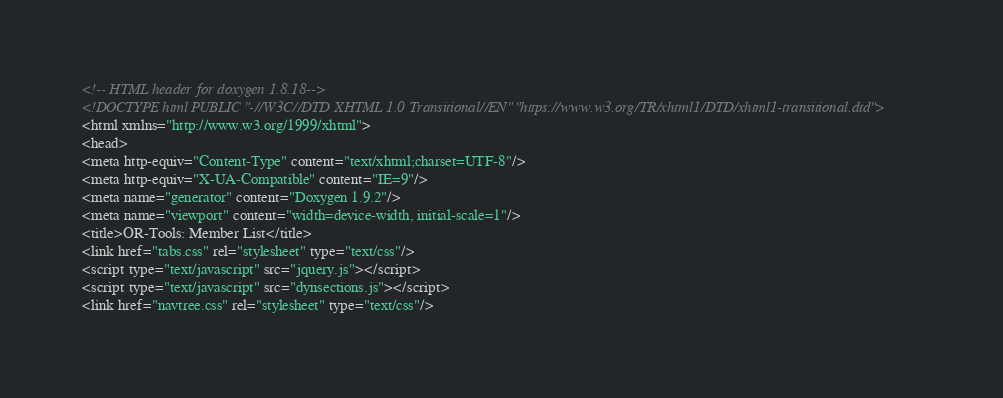Convert code to text. <code><loc_0><loc_0><loc_500><loc_500><_HTML_><!-- HTML header for doxygen 1.8.18-->
<!DOCTYPE html PUBLIC "-//W3C//DTD XHTML 1.0 Transitional//EN" "https://www.w3.org/TR/xhtml1/DTD/xhtml1-transitional.dtd">
<html xmlns="http://www.w3.org/1999/xhtml">
<head>
<meta http-equiv="Content-Type" content="text/xhtml;charset=UTF-8"/>
<meta http-equiv="X-UA-Compatible" content="IE=9"/>
<meta name="generator" content="Doxygen 1.9.2"/>
<meta name="viewport" content="width=device-width, initial-scale=1"/>
<title>OR-Tools: Member List</title>
<link href="tabs.css" rel="stylesheet" type="text/css"/>
<script type="text/javascript" src="jquery.js"></script>
<script type="text/javascript" src="dynsections.js"></script>
<link href="navtree.css" rel="stylesheet" type="text/css"/></code> 